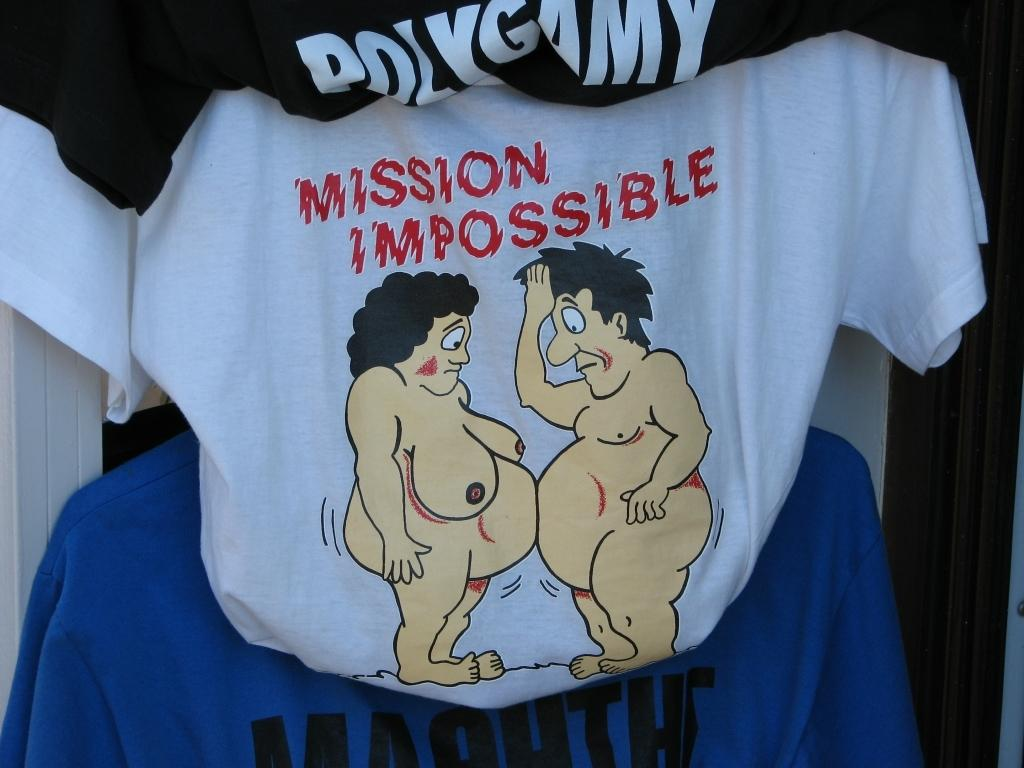<image>
Describe the image concisely. Some shirts hanging with one saying Mission Imppossible. 